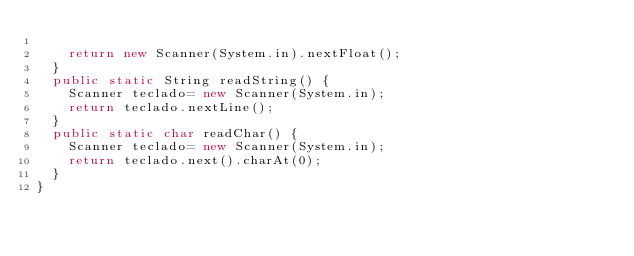<code> <loc_0><loc_0><loc_500><loc_500><_Java_>		
		return new Scanner(System.in).nextFloat();
	}
	public static String readString() {
		Scanner teclado= new Scanner(System.in);
		return teclado.nextLine();
	}
	public static char readChar() {
		Scanner teclado= new Scanner(System.in);
		return teclado.next().charAt(0);
	}
}
</code> 